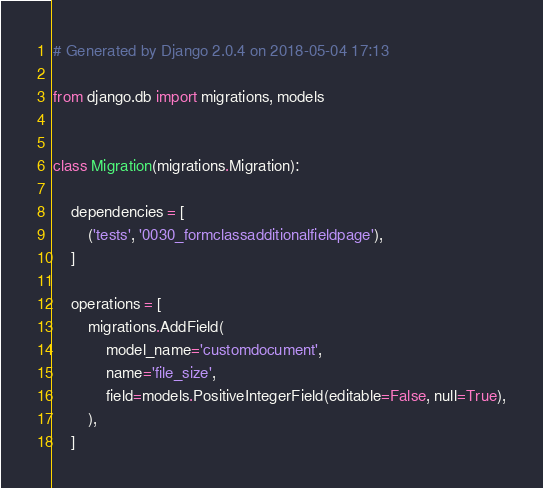<code> <loc_0><loc_0><loc_500><loc_500><_Python_># Generated by Django 2.0.4 on 2018-05-04 17:13

from django.db import migrations, models


class Migration(migrations.Migration):

    dependencies = [
        ('tests', '0030_formclassadditionalfieldpage'),
    ]

    operations = [
        migrations.AddField(
            model_name='customdocument',
            name='file_size',
            field=models.PositiveIntegerField(editable=False, null=True),
        ),
    ]
</code> 